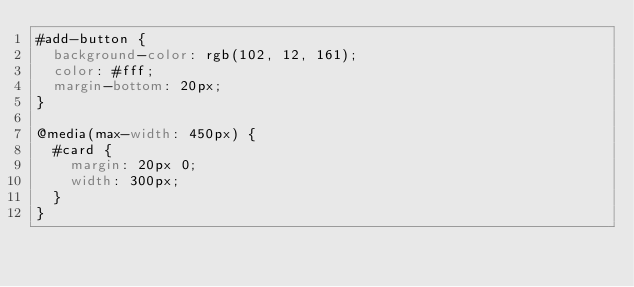Convert code to text. <code><loc_0><loc_0><loc_500><loc_500><_CSS_>#add-button {
  background-color: rgb(102, 12, 161);
  color: #fff;
  margin-bottom: 20px;
}

@media(max-width: 450px) {
  #card {
    margin: 20px 0;
    width: 300px;
  }
}
</code> 